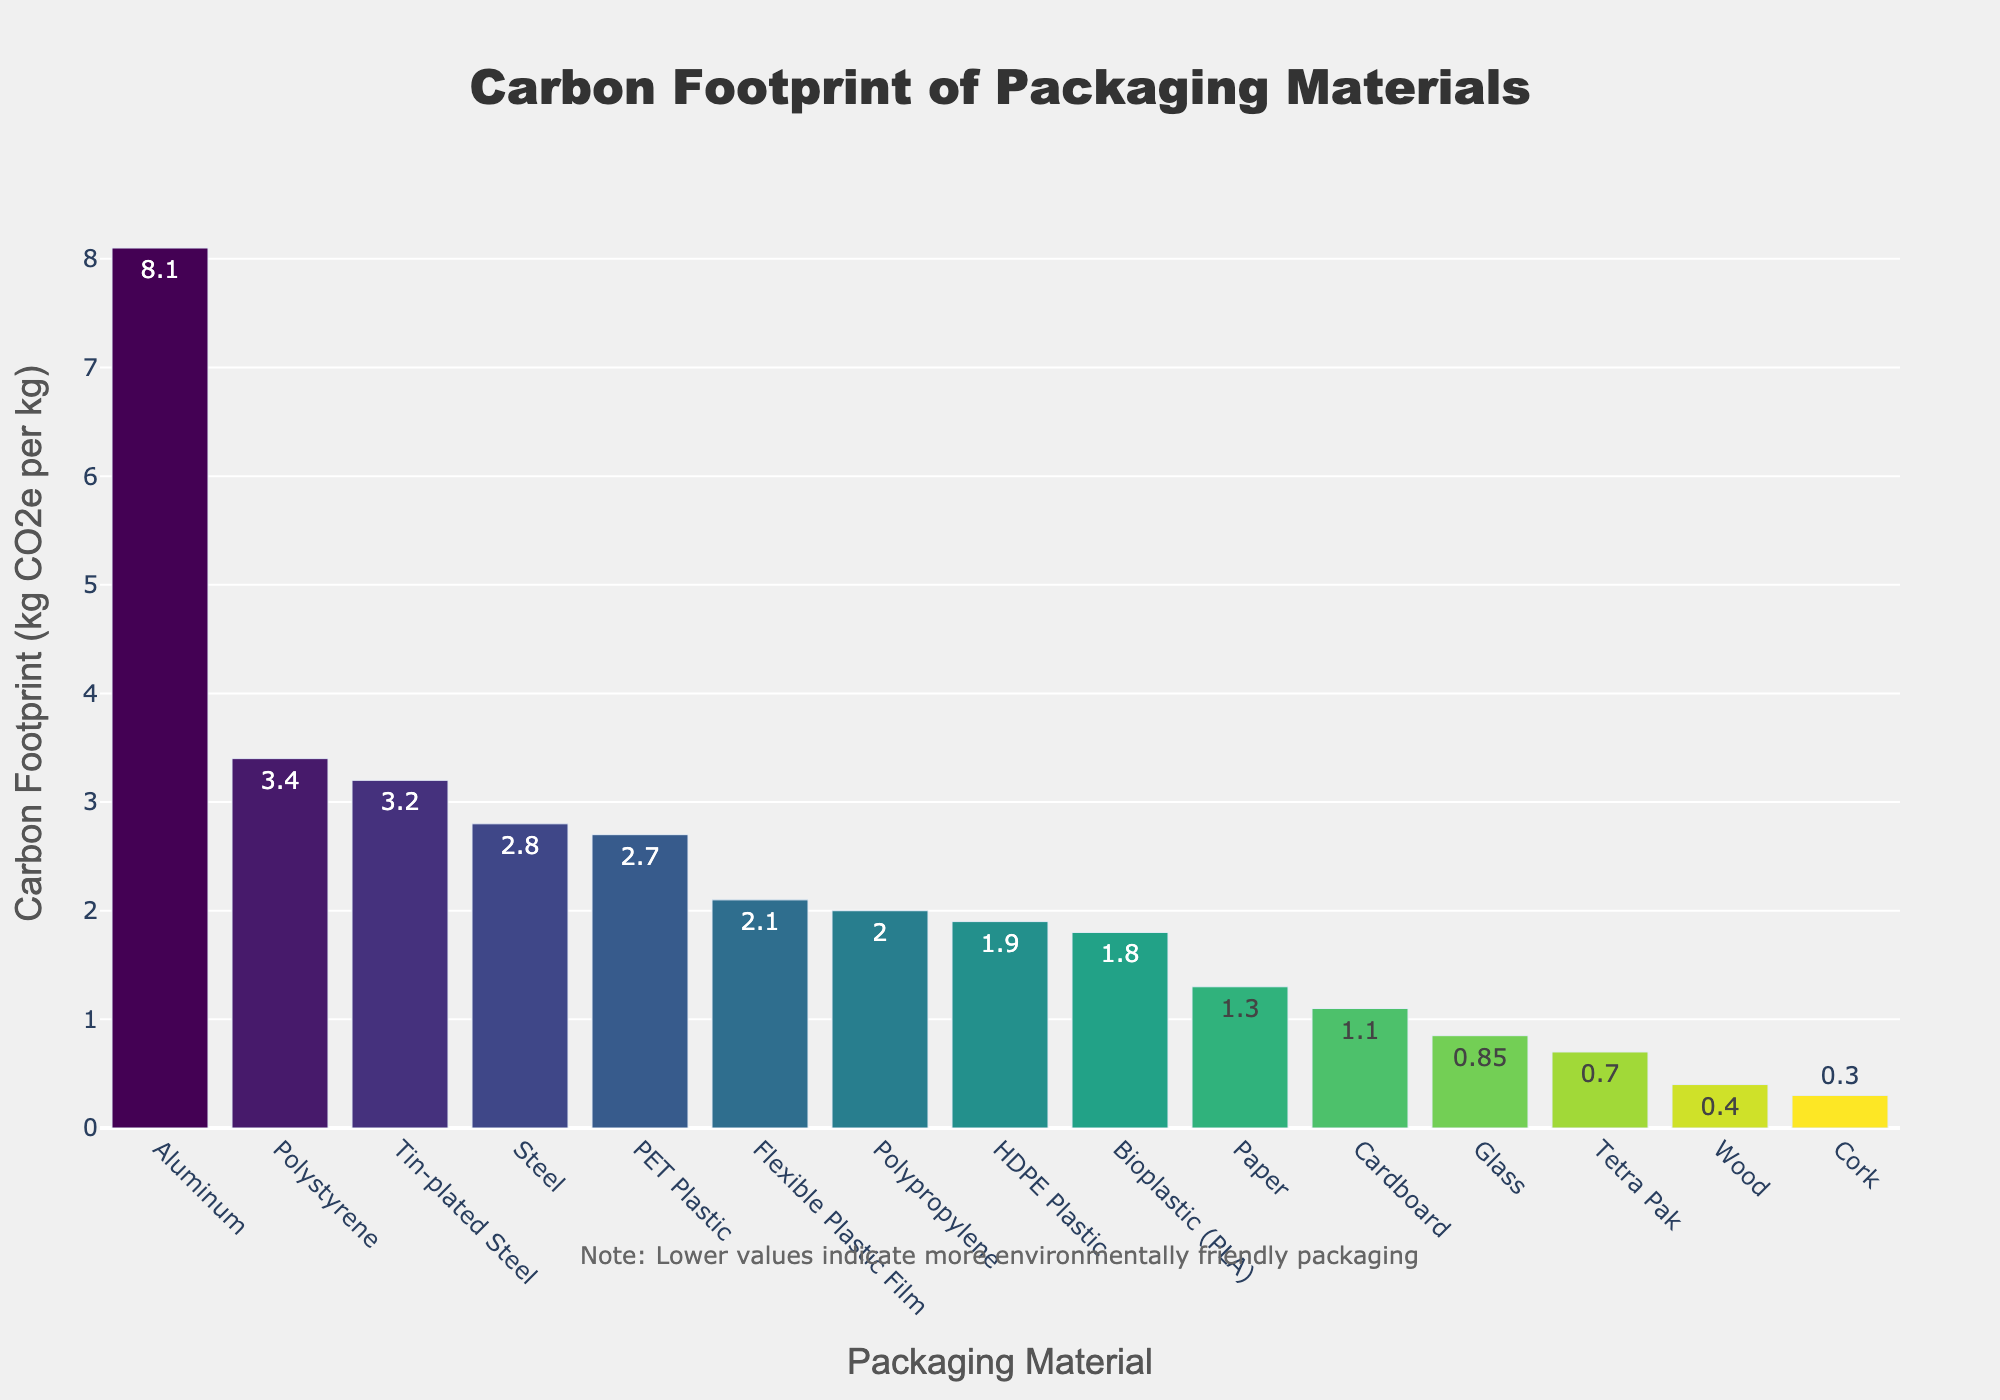Which material has the highest carbon footprint? The bar representing Aluminum is the tallest in the chart, with a carbon footprint of 8.1 kg CO2e per kg, indicating it has the highest value.
Answer: Aluminum Which material has the lowest carbon footprint? The bar representing Cork is the shortest in the chart, with a carbon footprint of 0.3 kg CO2e per kg, indicating it has the lowest value.
Answer: Cork What is the difference between the carbon footprint of Aluminum and Glass? Aluminum has a carbon footprint of 8.1 kg CO2e per kg and Glass has 0.85 kg CO2e per kg. The difference is 8.1 - 0.85 = 7.25.
Answer: 7.25 Which materials have a carbon footprint less than 1 kg CO2e per kg? The bars representing Tetra Pak, Wood, and Cork are all shorter and have values less than 1: Tetra Pak (0.7), Wood (0.4), Cork (0.3).
Answer: Tetra Pak, Wood, Cork Which has a larger carbon footprint: PET Plastic or HDPE Plastic? The bar representing PET Plastic (2.7) is taller than HDPE Plastic (1.9), indicating PET Plastic has a larger carbon footprint.
Answer: PET Plastic By how much does the carbon footprint of Polystyrene exceed that of Flexible Plastic Film? Polystyrene has a footprint of 3.4 kg CO2e per kg and Flexible Plastic Film has 2.1 kg CO2e per kg. The difference is 3.4 - 2.1 = 1.3.
Answer: 1.3 What is the median carbon footprint value among these materials? To find the median, list all values: 0.3, 0.4, 0.7, 0.85, 1.1, 1.3, 1.8, 1.9, 2.0, 2.1, 2.7, 2.8, 3.2, 3.4, 8.1. The median is the 8th value: 1.9.
Answer: 1.9 How do the carbon footprints of Paper and Cardboard compare visually? The height of the bar for Paper is slightly taller than that for Cardboard. Paper: 1.3 kg CO2e per kg, Cardboard: 1.1 kg CO2e per kg.
Answer: Paper is higher Which material has the carbon footprint closest to the average of all materials? Calculate the average: (0.3+0.4+0.7+0.85+1.1+1.3+1.8+1.9+2.0+2.1+2.7+2.8+3.2+3.4+8.1) / 15 = 2.17 kg CO2e per kg. Flexible Plastic Film, at 2.1, is closest.
Answer: Flexible Plastic Film 